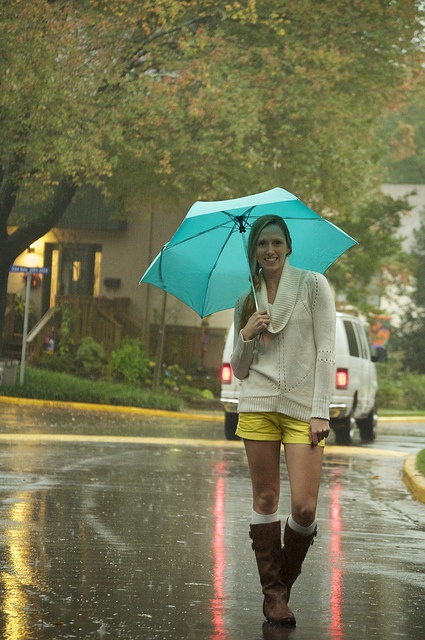Describe the objects in this image and their specific colors. I can see people in darkgreen, darkgray, black, gray, and olive tones, umbrella in darkgreen, teal, turquoise, and lightblue tones, truck in darkgreen, darkgray, lightgray, gray, and beige tones, and car in darkgreen, darkgray, lightgray, black, and beige tones in this image. 